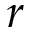<formula> <loc_0><loc_0><loc_500><loc_500>r</formula> 